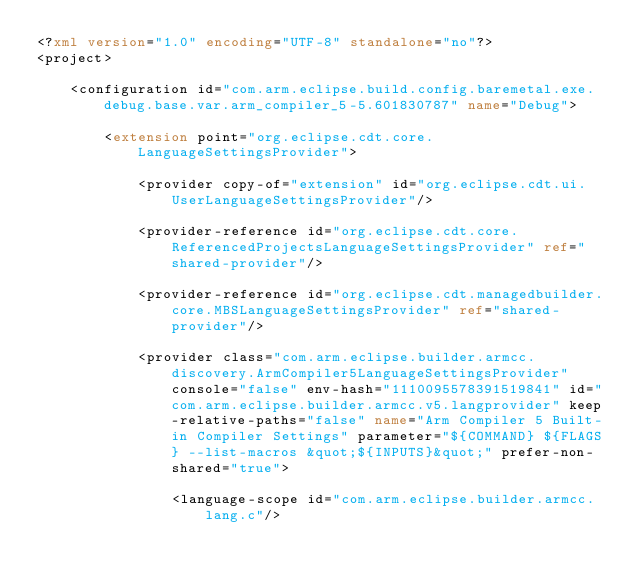Convert code to text. <code><loc_0><loc_0><loc_500><loc_500><_XML_><?xml version="1.0" encoding="UTF-8" standalone="no"?>
<project>
    	
    <configuration id="com.arm.eclipse.build.config.baremetal.exe.debug.base.var.arm_compiler_5-5.601830787" name="Debug">
        		
        <extension point="org.eclipse.cdt.core.LanguageSettingsProvider">
            			
            <provider copy-of="extension" id="org.eclipse.cdt.ui.UserLanguageSettingsProvider"/>
            			
            <provider-reference id="org.eclipse.cdt.core.ReferencedProjectsLanguageSettingsProvider" ref="shared-provider"/>
            			
            <provider-reference id="org.eclipse.cdt.managedbuilder.core.MBSLanguageSettingsProvider" ref="shared-provider"/>
            			
            <provider class="com.arm.eclipse.builder.armcc.discovery.ArmCompiler5LanguageSettingsProvider" console="false" env-hash="1110095578391519841" id="com.arm.eclipse.builder.armcc.v5.langprovider" keep-relative-paths="false" name="Arm Compiler 5 Built-in Compiler Settings" parameter="${COMMAND} ${FLAGS} --list-macros &quot;${INPUTS}&quot;" prefer-non-shared="true">
                				
                <language-scope id="com.arm.eclipse.builder.armcc.lang.c"/>
                				</code> 